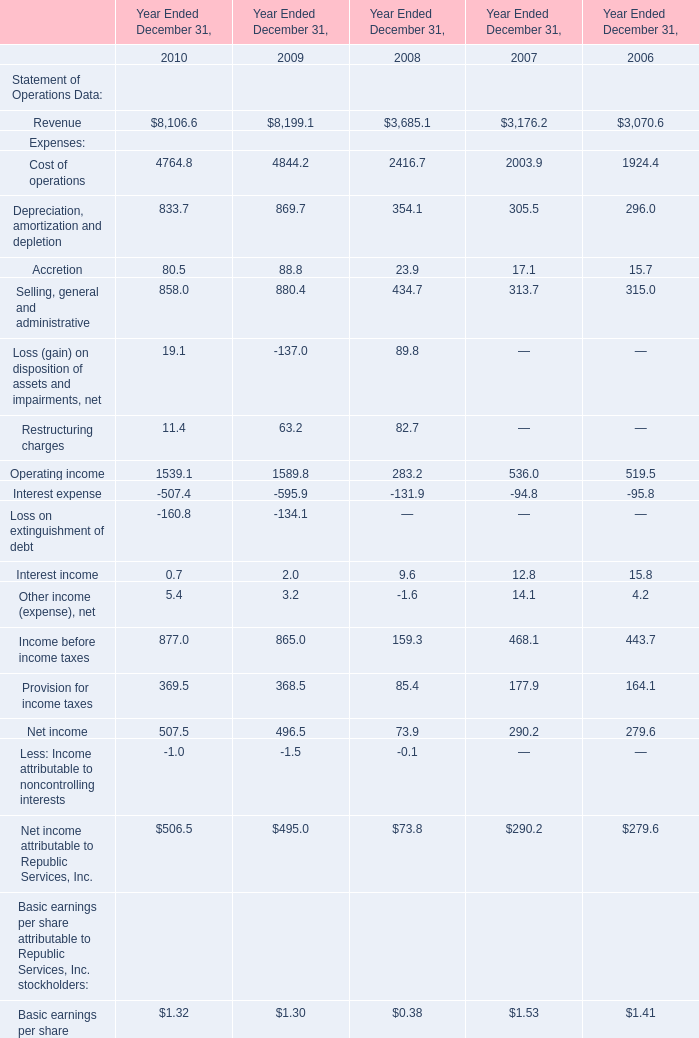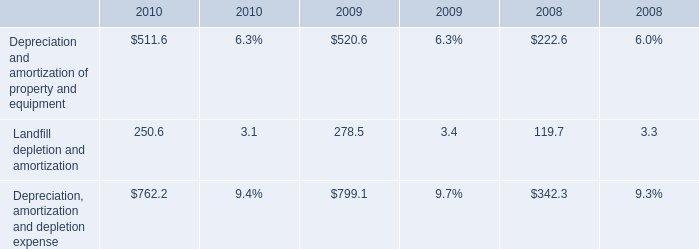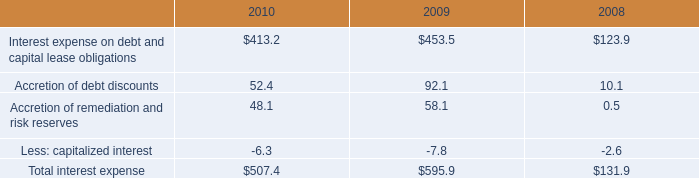What is the ratio of Cost of operations for Expenses to the Landfill depletion and amortization for amount in 2010? 
Computations: (4764.8 / 250.6)
Answer: 19.01357. 